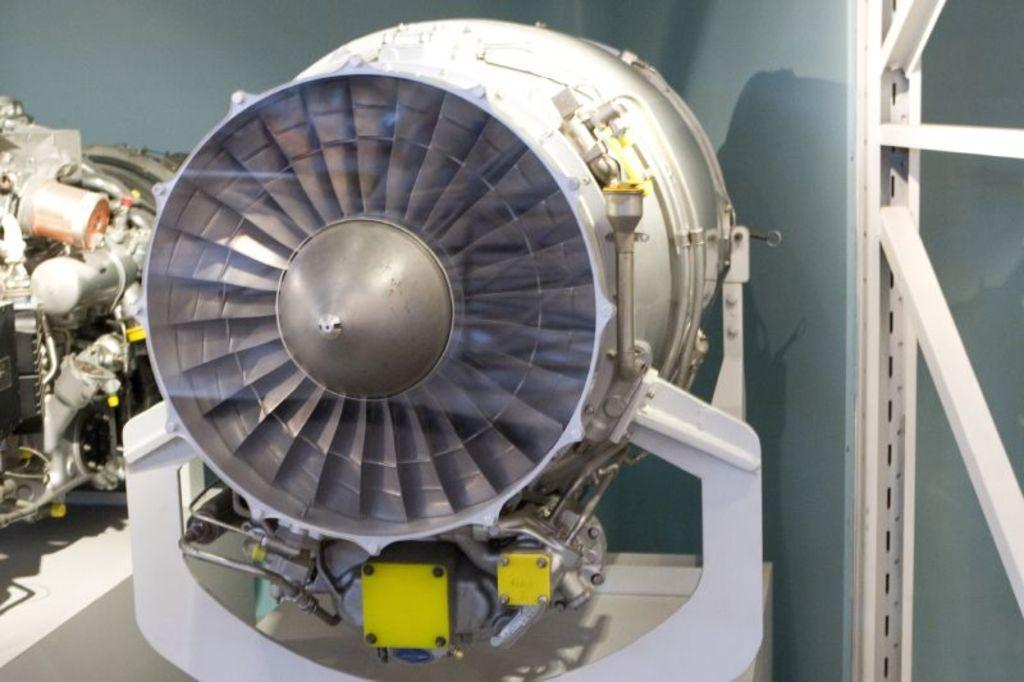What can be seen in the image? There are machines in the image. Where are the machines located? The machines are in a room. What type of knife is being used by the judge in the image? There is no knife or judge present in the image; it only features machines in a room. 